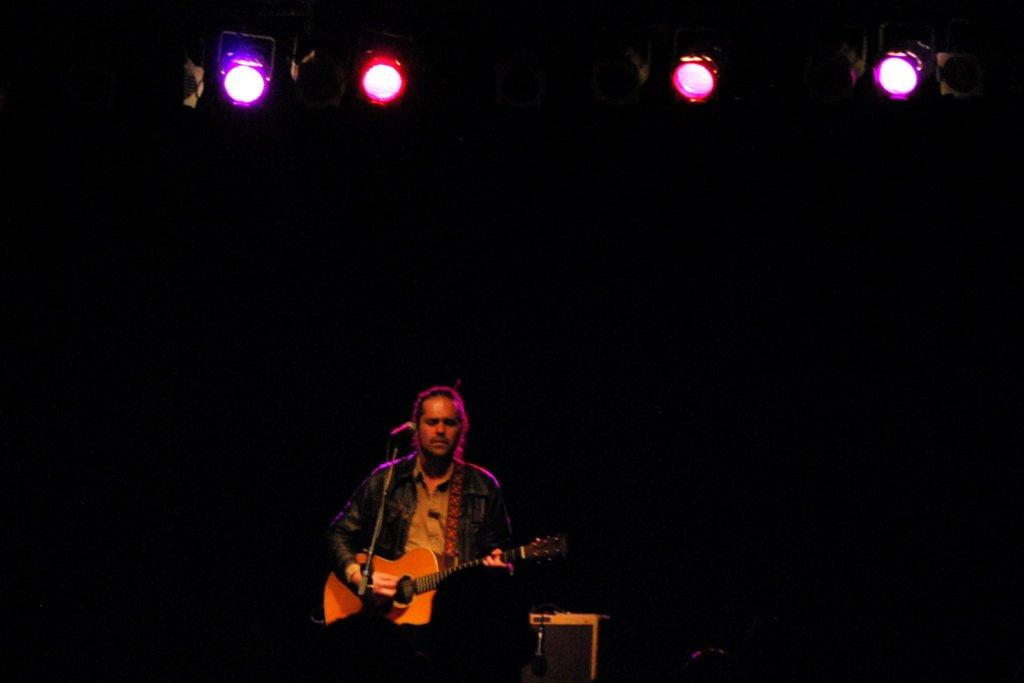What is the man in the image doing? The man is playing a guitar. What object is in front of the man? There is a microphone in front of the man. Where is the man located in the image? The man is on a stage. What is the man's brother saying to him as he plays the guitar in the image? There is no information about a brother or any dialogue in the image. 